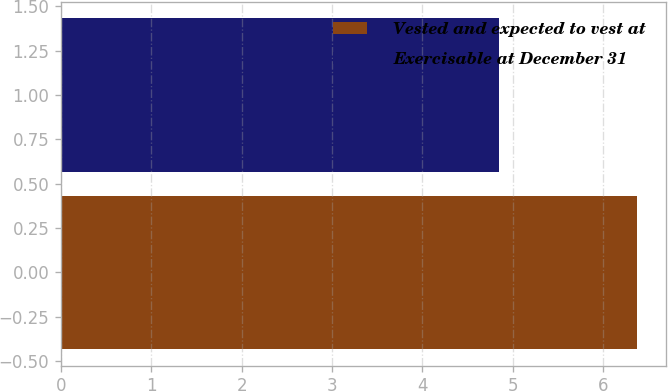<chart> <loc_0><loc_0><loc_500><loc_500><bar_chart><fcel>Vested and expected to vest at<fcel>Exercisable at December 31<nl><fcel>6.38<fcel>4.85<nl></chart> 